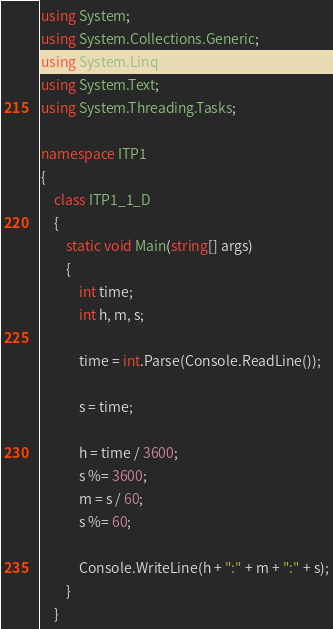Convert code to text. <code><loc_0><loc_0><loc_500><loc_500><_C#_>using System;
using System.Collections.Generic;
using System.Linq;
using System.Text;
using System.Threading.Tasks;

namespace ITP1
{
    class ITP1_1_D
    {
        static void Main(string[] args)
        {
            int time;
            int h, m, s;

            time = int.Parse(Console.ReadLine());

            s = time;

            h = time / 3600;
            s %= 3600;
            m = s / 60;
            s %= 60;
      
            Console.WriteLine(h + ":" + m + ":" + s);
        }
    }
</code> 